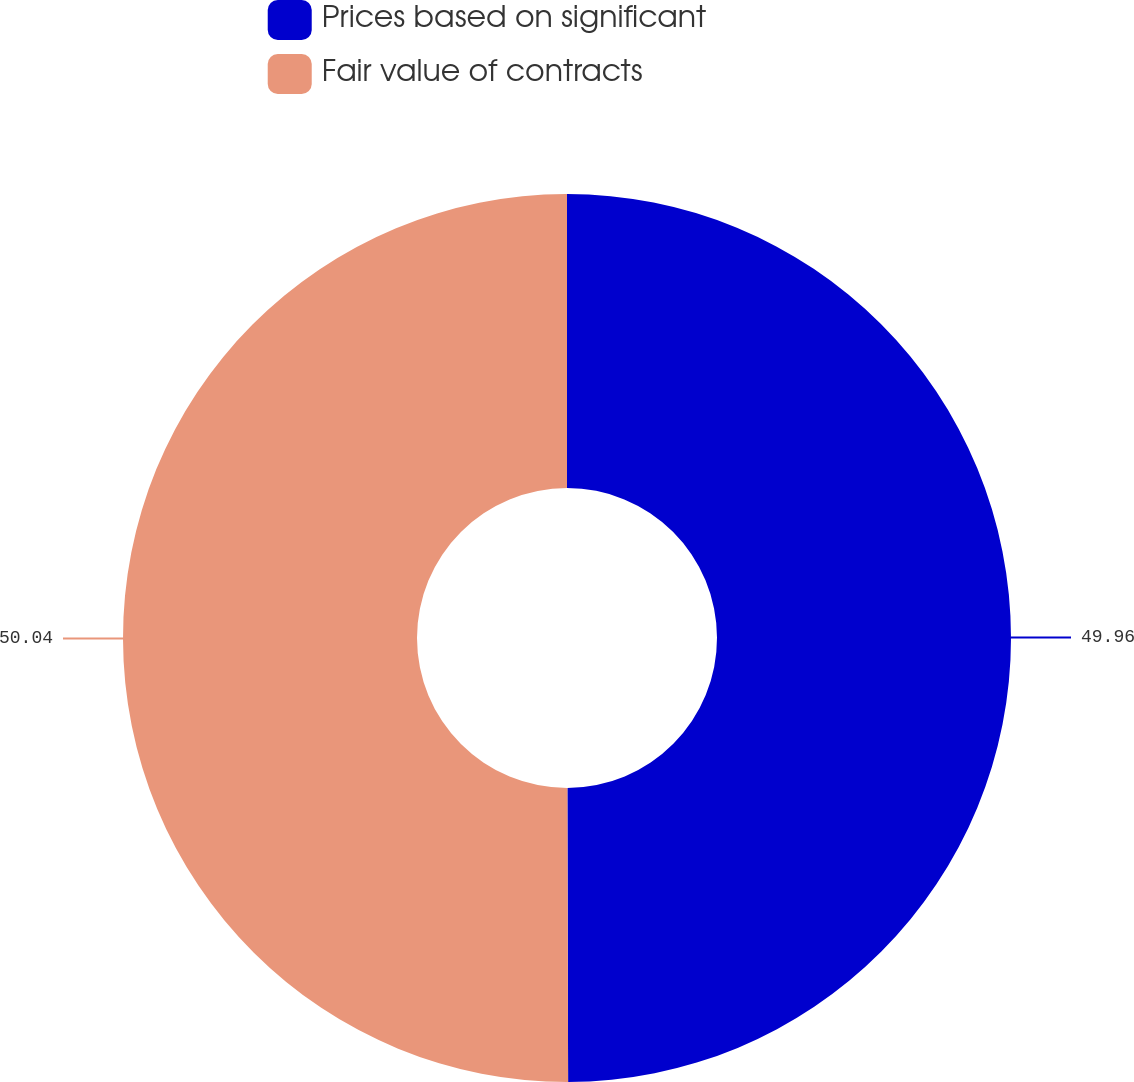<chart> <loc_0><loc_0><loc_500><loc_500><pie_chart><fcel>Prices based on significant<fcel>Fair value of contracts<nl><fcel>49.96%<fcel>50.04%<nl></chart> 